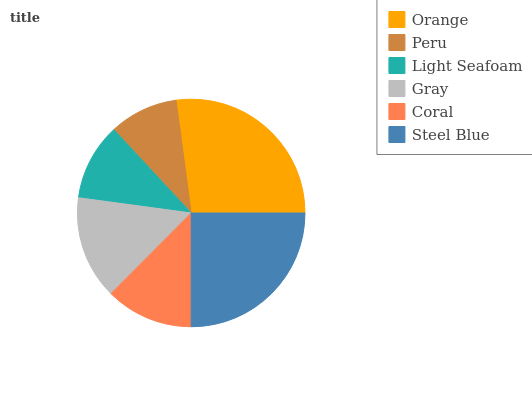Is Peru the minimum?
Answer yes or no. Yes. Is Orange the maximum?
Answer yes or no. Yes. Is Light Seafoam the minimum?
Answer yes or no. No. Is Light Seafoam the maximum?
Answer yes or no. No. Is Light Seafoam greater than Peru?
Answer yes or no. Yes. Is Peru less than Light Seafoam?
Answer yes or no. Yes. Is Peru greater than Light Seafoam?
Answer yes or no. No. Is Light Seafoam less than Peru?
Answer yes or no. No. Is Gray the high median?
Answer yes or no. Yes. Is Coral the low median?
Answer yes or no. Yes. Is Orange the high median?
Answer yes or no. No. Is Light Seafoam the low median?
Answer yes or no. No. 